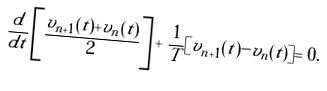<formula> <loc_0><loc_0><loc_500><loc_500>\frac { d } { d t } \left [ \frac { v _ { n + 1 } ( t ) + v _ { n } ( t ) } { 2 } \right ] + \frac { 1 } { T } [ v _ { n + 1 } ( t ) - v _ { n } ( t ) ] = 0 .</formula> 